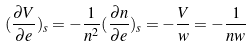<formula> <loc_0><loc_0><loc_500><loc_500>( \frac { \partial V } { \partial e } ) _ { s } = - \frac { 1 } { n ^ { 2 } } ( \frac { \partial n } { \partial e } ) _ { s } = - \frac { V } { w } = - \frac { 1 } { n w }</formula> 